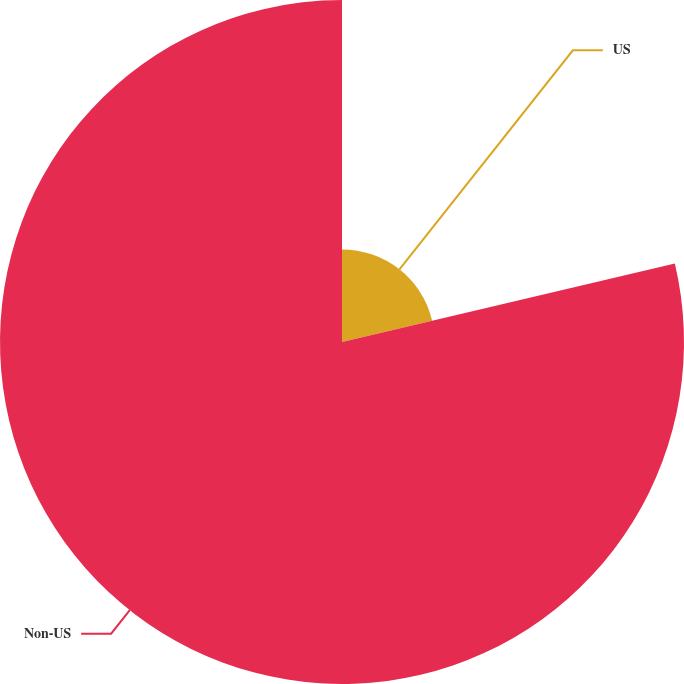Convert chart. <chart><loc_0><loc_0><loc_500><loc_500><pie_chart><fcel>US<fcel>Non-US<nl><fcel>21.31%<fcel>78.69%<nl></chart> 